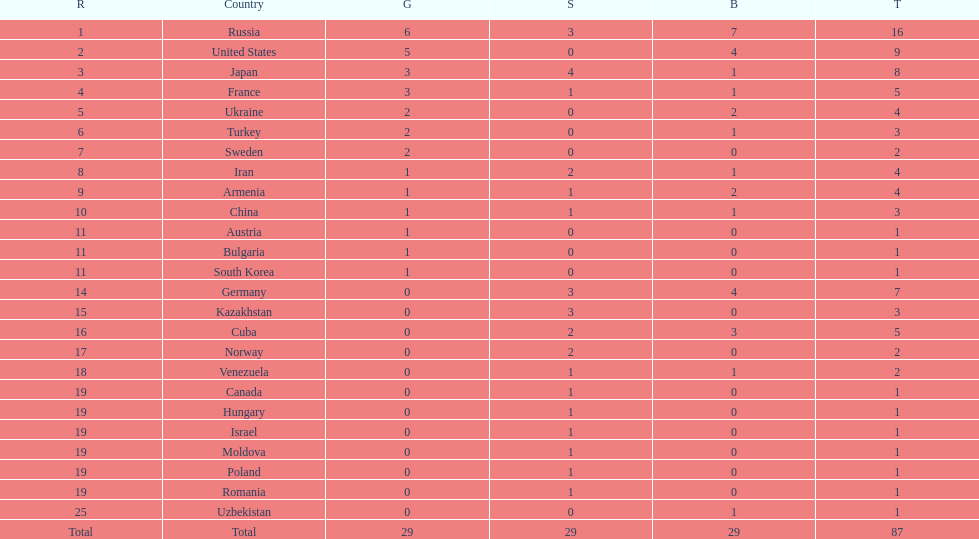How many silver medals did turkey win? 0. 